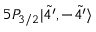<formula> <loc_0><loc_0><loc_500><loc_500>5 P _ { 3 / 2 } | \tilde { 4 ^ { \prime } } , - \tilde { 4 ^ { \prime } } \rangle</formula> 